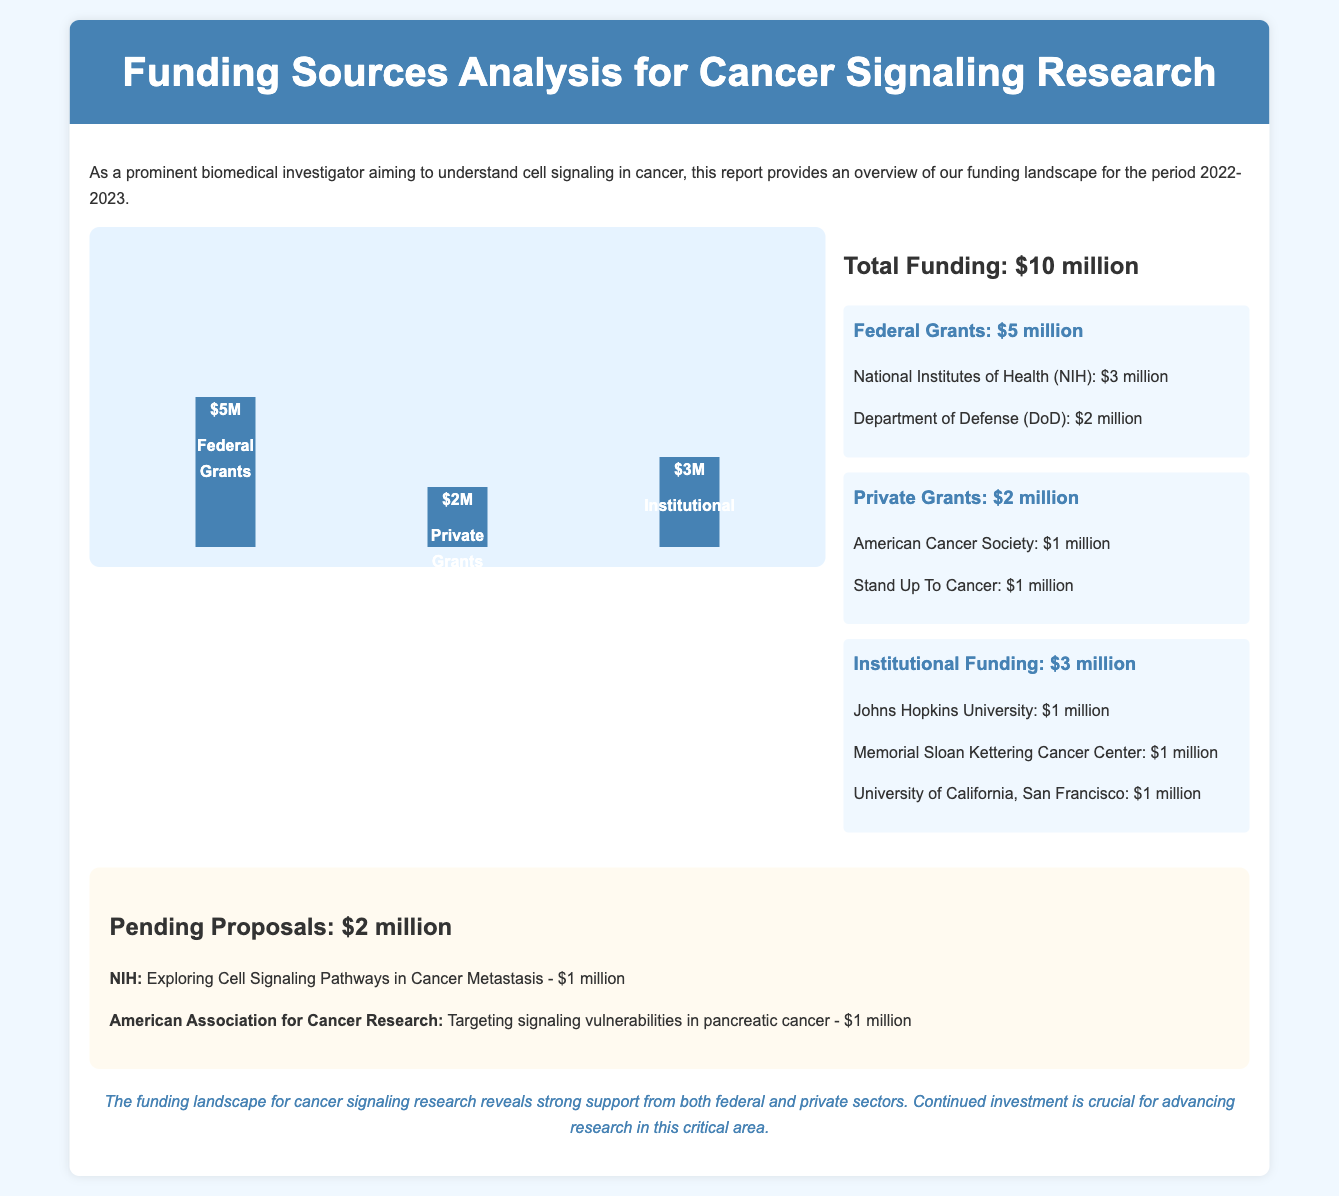What is the total funding? The total funding is presented in the document, which aggregates different sources of funding, totaling $10 million.
Answer: $10 million How much was received from federal grants? The document specifies the amount received from federal grants, which totals $5 million.
Answer: $5 million What organization provided the largest amount in private grants? The document lists private grants and specifies that the American Cancer Society is one of the contributors, receiving $1 million.
Answer: American Cancer Society How many million dollars is in pending proposals? The pending proposals section indicates a total of $2 million for pending proposals.
Answer: $2 million Which federal agency contributed $3 million? The document states that the National Institutes of Health contributed $3 million in federal grants.
Answer: National Institutes of Health What is the amount from institutional funding? The document indicates that the total amount received from institutional funding is $3 million.
Answer: $3 million What are the two organizations listed under pending proposals? In the pending proposals section, two organizations are mentioned: NIH and American Association for Cancer Research.
Answer: NIH and American Association for Cancer Research Which source provided funding for Johns Hopkins University? The document specifies that Johns Hopkins University is funded under institutional funding, totaling $1 million.
Answer: Institutional funding 